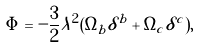<formula> <loc_0><loc_0><loc_500><loc_500>\Phi = - \frac { 3 } { 2 } \lambda ^ { 2 } ( \Omega _ { b } \delta ^ { b } + \Omega _ { c } \delta ^ { c } ) , \</formula> 